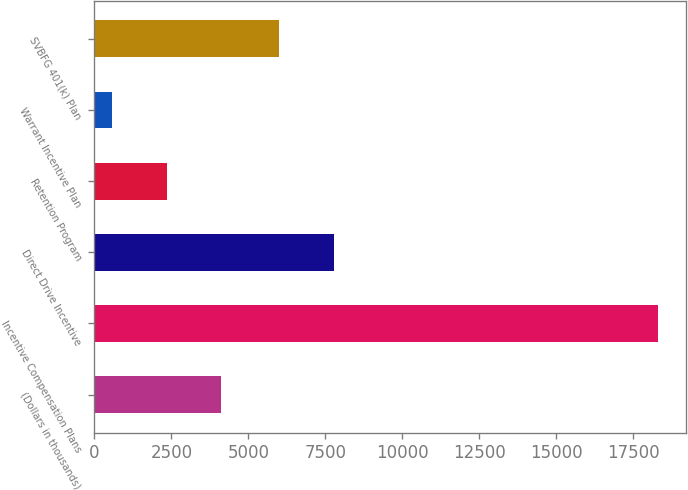<chart> <loc_0><loc_0><loc_500><loc_500><bar_chart><fcel>(Dollars in thousands)<fcel>Incentive Compensation Plans<fcel>Direct Drive Incentive<fcel>Retention Program<fcel>Warrant Incentive Plan<fcel>SVBFG 401(k) Plan<nl><fcel>4119.4<fcel>18285<fcel>7780.7<fcel>2348.7<fcel>578<fcel>6010<nl></chart> 